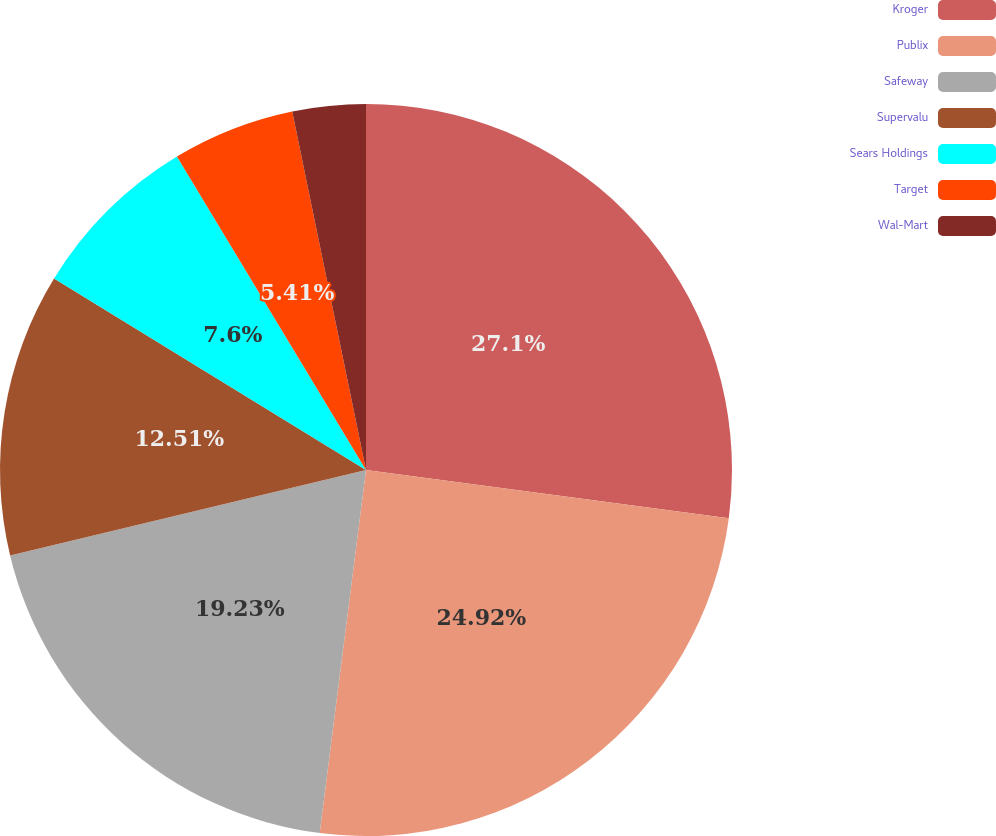<chart> <loc_0><loc_0><loc_500><loc_500><pie_chart><fcel>Kroger<fcel>Publix<fcel>Safeway<fcel>Supervalu<fcel>Sears Holdings<fcel>Target<fcel>Wal-Mart<nl><fcel>27.1%<fcel>24.92%<fcel>19.23%<fcel>12.51%<fcel>7.6%<fcel>5.41%<fcel>3.23%<nl></chart> 